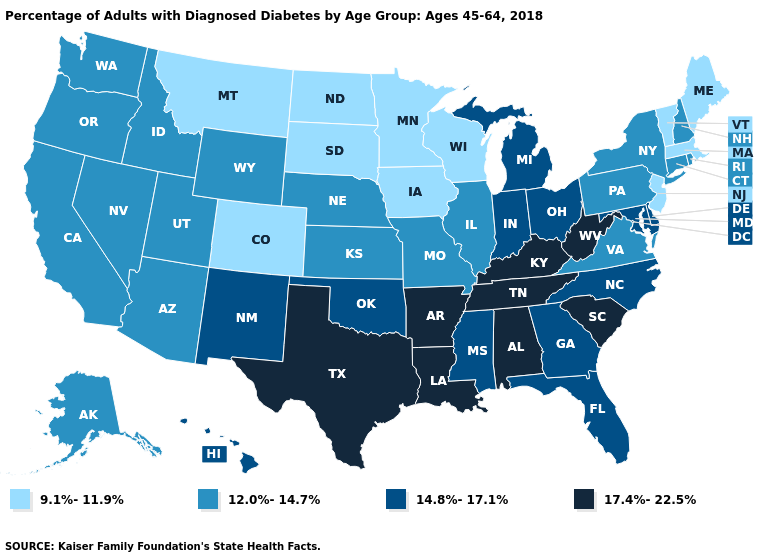Does Colorado have the same value as Minnesota?
Be succinct. Yes. Which states hav the highest value in the Northeast?
Give a very brief answer. Connecticut, New Hampshire, New York, Pennsylvania, Rhode Island. Does Missouri have the lowest value in the USA?
Give a very brief answer. No. Among the states that border Rhode Island , which have the lowest value?
Answer briefly. Massachusetts. What is the value of Missouri?
Be succinct. 12.0%-14.7%. Does Pennsylvania have the lowest value in the Northeast?
Give a very brief answer. No. What is the value of Rhode Island?
Concise answer only. 12.0%-14.7%. Which states hav the highest value in the West?
Give a very brief answer. Hawaii, New Mexico. Among the states that border Montana , does Wyoming have the highest value?
Quick response, please. Yes. What is the value of Nevada?
Give a very brief answer. 12.0%-14.7%. Which states have the lowest value in the Northeast?
Be succinct. Maine, Massachusetts, New Jersey, Vermont. Among the states that border Kansas , which have the highest value?
Answer briefly. Oklahoma. Which states have the lowest value in the USA?
Short answer required. Colorado, Iowa, Maine, Massachusetts, Minnesota, Montana, New Jersey, North Dakota, South Dakota, Vermont, Wisconsin. What is the value of Colorado?
Answer briefly. 9.1%-11.9%. What is the value of Utah?
Concise answer only. 12.0%-14.7%. 